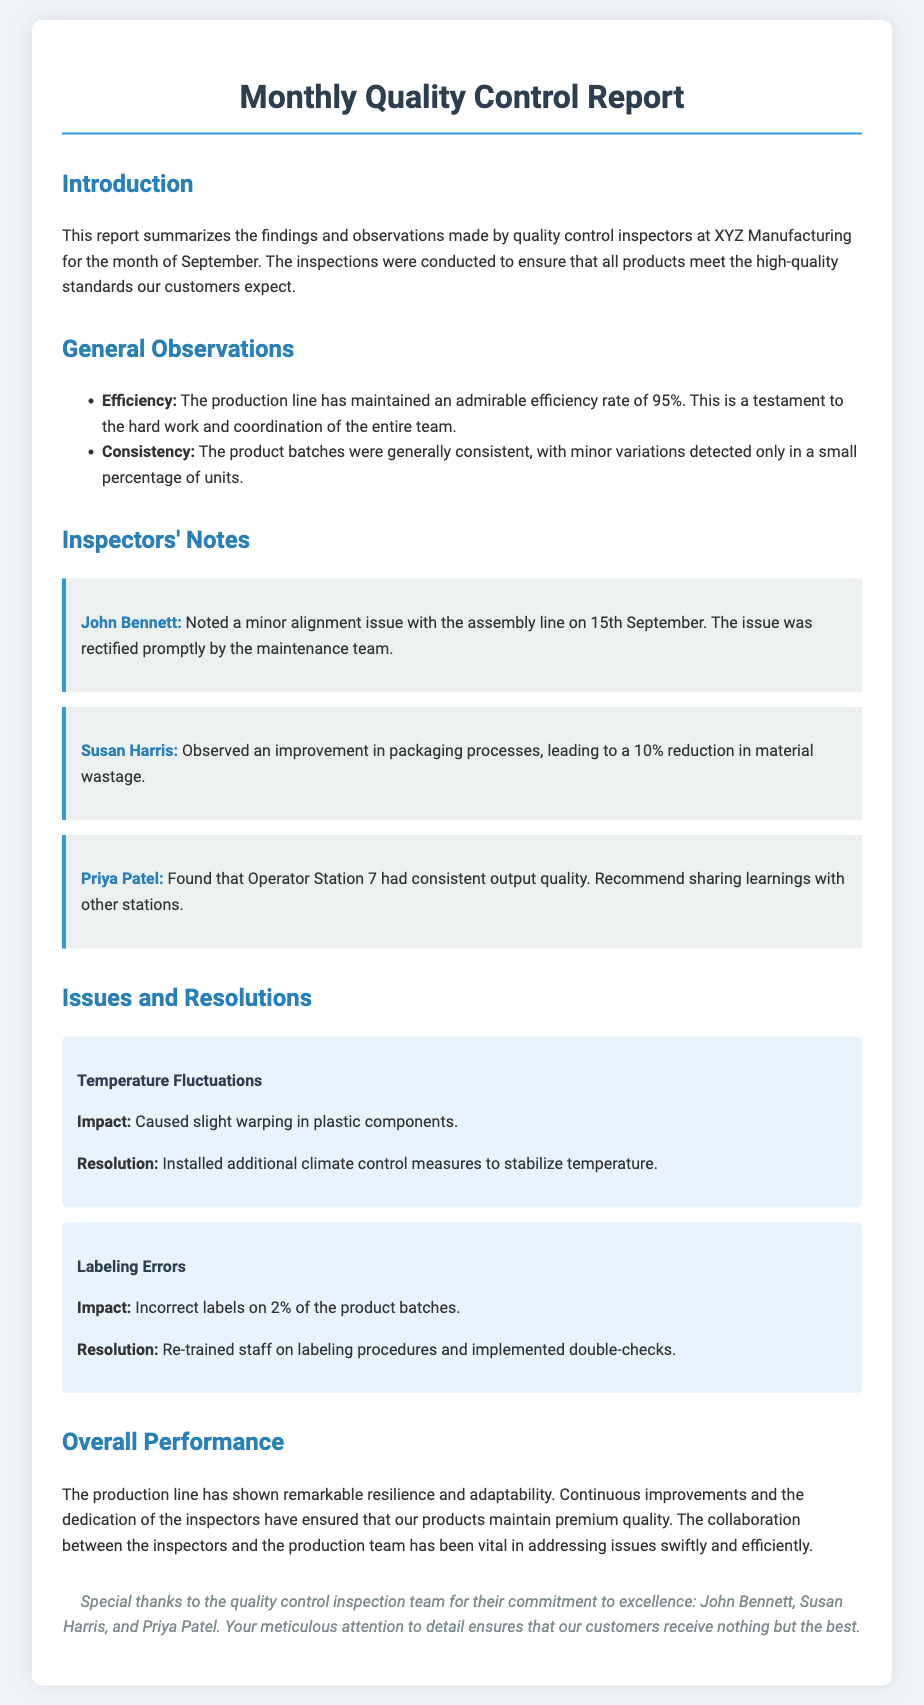What is the efficiency rate of the production line? The efficiency rate is stated in the report as 95%, showing the team's hard work and coordination.
Answer: 95% Who noted a minor alignment issue on 15th September? John Bennett is the inspector who noted the minor alignment issue with the assembly line on that date.
Answer: John Bennett What improvement did Susan Harris observe? The report highlights a 10% reduction in material wastage due to improvements in packaging processes as observed by Susan Harris.
Answer: 10% What was the impact of temperature fluctuations? Temperature fluctuations caused slight warping in plastic components based on the issues outlined in the report.
Answer: Warping Which operator station had consistent output quality? Priya Patel reported consistent output quality from Operator Station 7, indicating its reliability in the production process.
Answer: Operator Station 7 What training was implemented to address labeling errors? The staff was re-trained on labeling procedures following the identification of labeling errors in the product batches.
Answer: Re-trained staff What month does the report cover? The report summarizes findings and observations for the month of September.
Answer: September Who are the inspectors acknowledged for their commitment? The report specifically acknowledges John Bennett, Susan Harris, and Priya Patel for their meticulous attention to detail.
Answer: John Bennett, Susan Harris, and Priya Patel What measures were installed to manage temperature fluctuations? The report mentions that additional climate control measures were installed to stabilize the temperature affecting production quality.
Answer: Additional climate control measures 